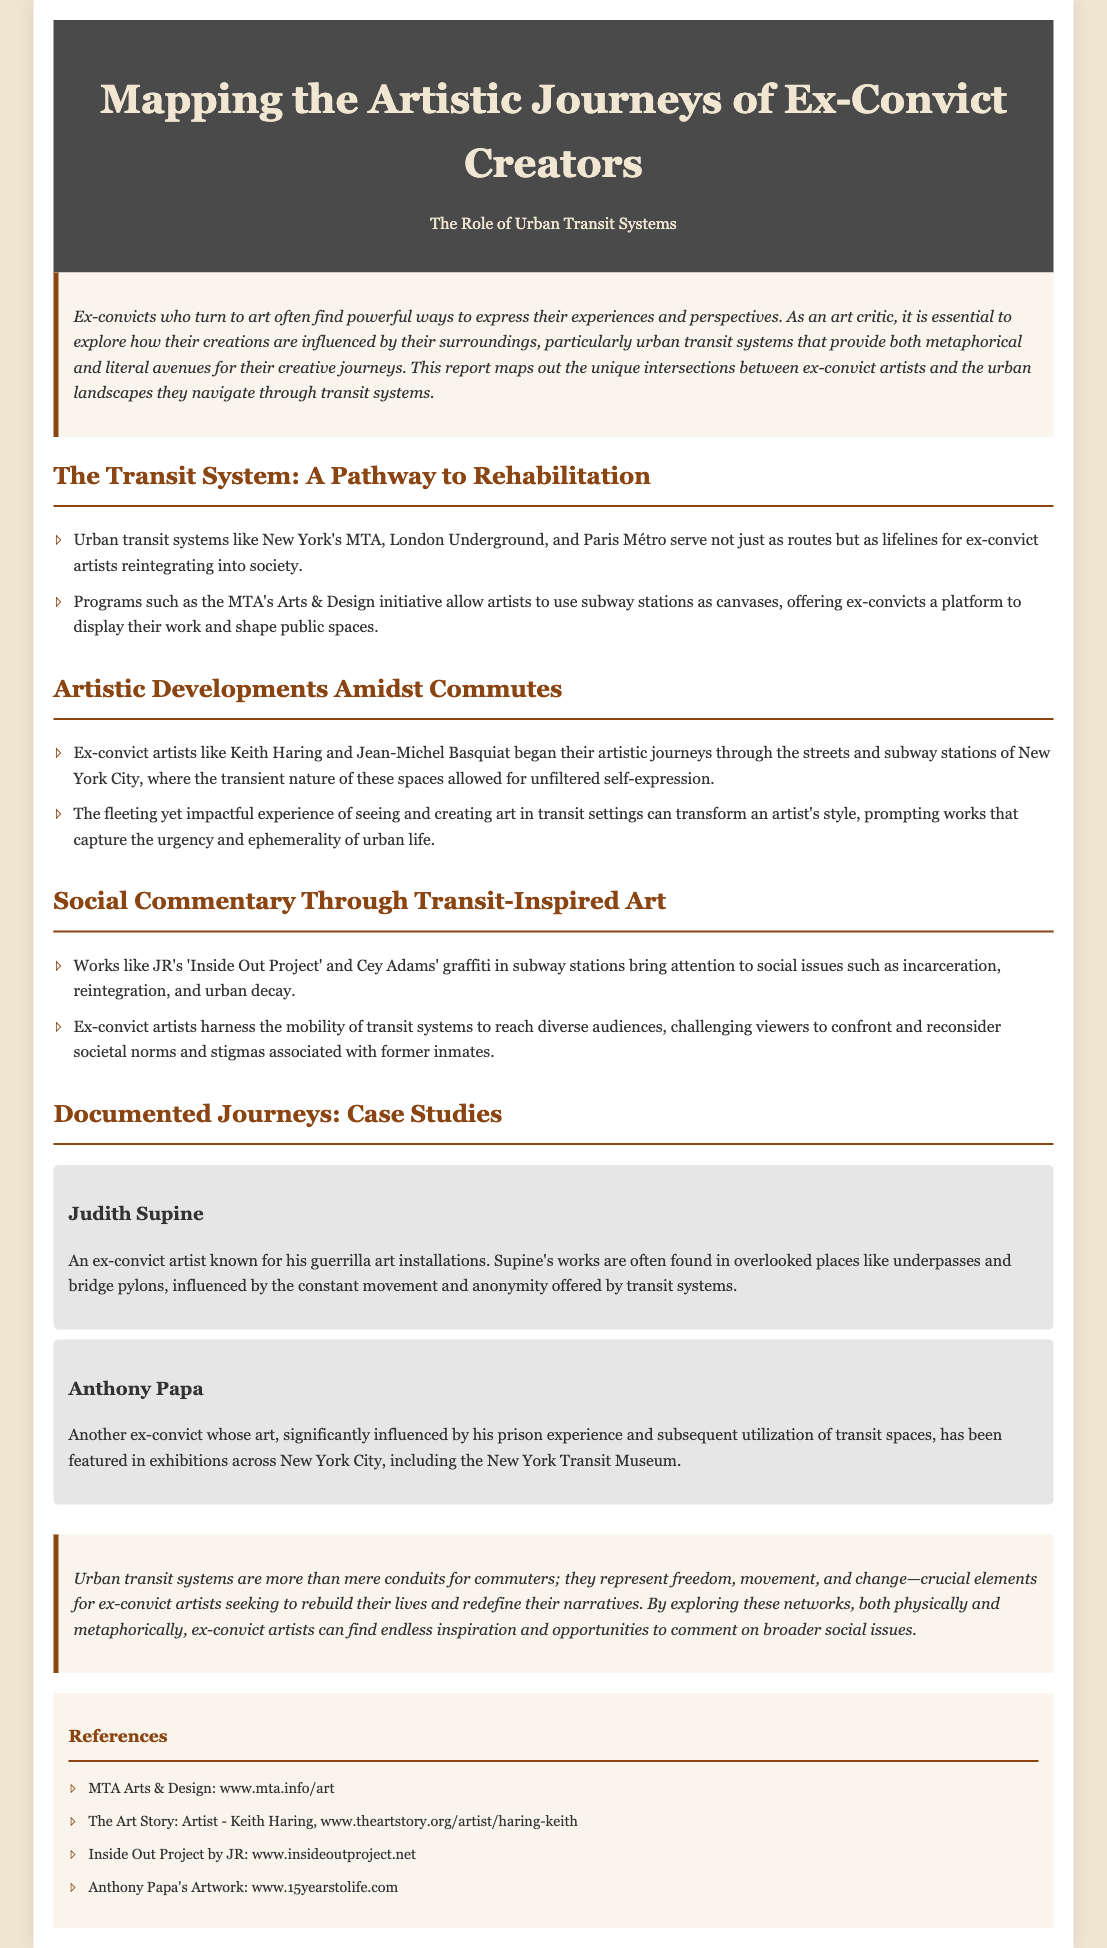What are the names of two ex-convict artists mentioned? The document lists Keith Haring and Jean-Michel Basquiat as ex-convict artists.
Answer: Keith Haring, Jean-Michel Basquiat What program allows artists to use subway stations as canvases? The MTA's Arts & Design initiative is mentioned as a program for this purpose.
Answer: MTA's Arts & Design Which city is home to the New York Transit Museum? The document refers to New York City where the museum is located.
Answer: New York City What type of art is Judith Supine known for? The document describes Judith Supine's work as guerrilla art installations.
Answer: Guerrilla art installations What is a theme explored in JR's 'Inside Out Project'? The document states that this project addresses social issues such as incarceration and reintegration.
Answer: Incarceration and reintegration How does urban transit influence ex-convict artists? The document indicates that urban transit provides both metaphorical and literal avenues for creative journeys.
Answer: Metaphorical and literal avenues What social issue is highlighted through Cey Adams' graffiti? The document mentions that his graffiti brings attention to urban decay.
Answer: Urban decay What role do urban transit systems play according to the conclusion? The conclusion states that transit systems represent freedom, movement, and change for ex-convict artists.
Answer: Freedom, movement, and change 